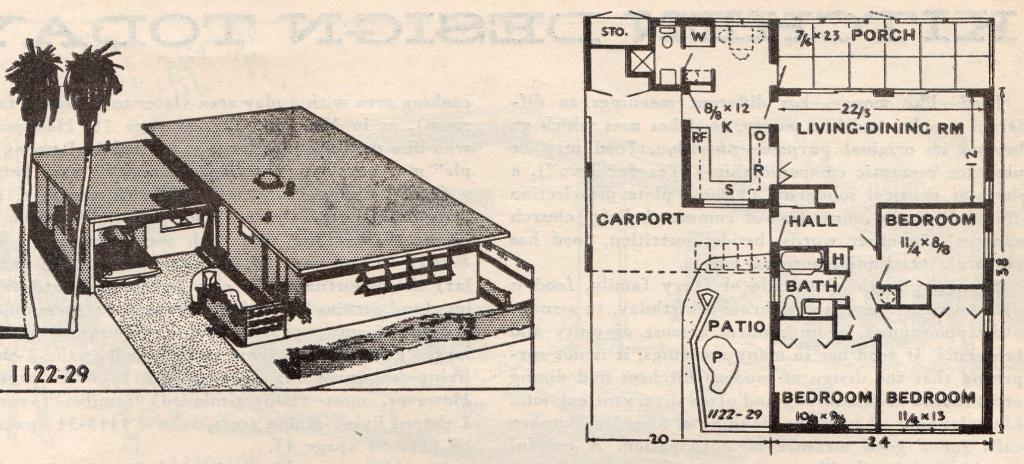What is the main subject of the paper in the image? The paper contains photos of a house. Are there any other elements depicted on the paper besides the house? Yes, there are trees depicted on the paper. What type of information is included on the paper? Numbers and words are present on the paper, along with measurements of the interior part of the house. How many oranges are hanging from the trees depicted on the paper? There are no oranges depicted on the paper; it only shows trees. What time is displayed on the watch in the image? There is no watch present in the image. 